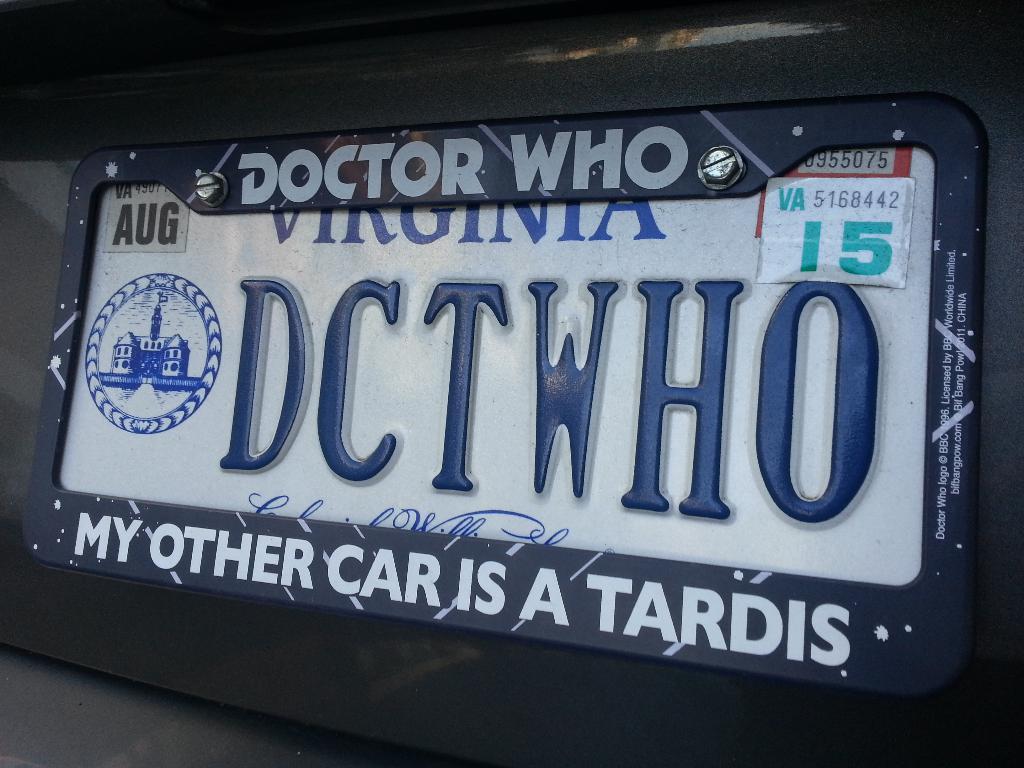What is their other car?
Provide a short and direct response. Tardis. Which show is named on the top of the license plate frame?
Keep it short and to the point. Doctor who. 